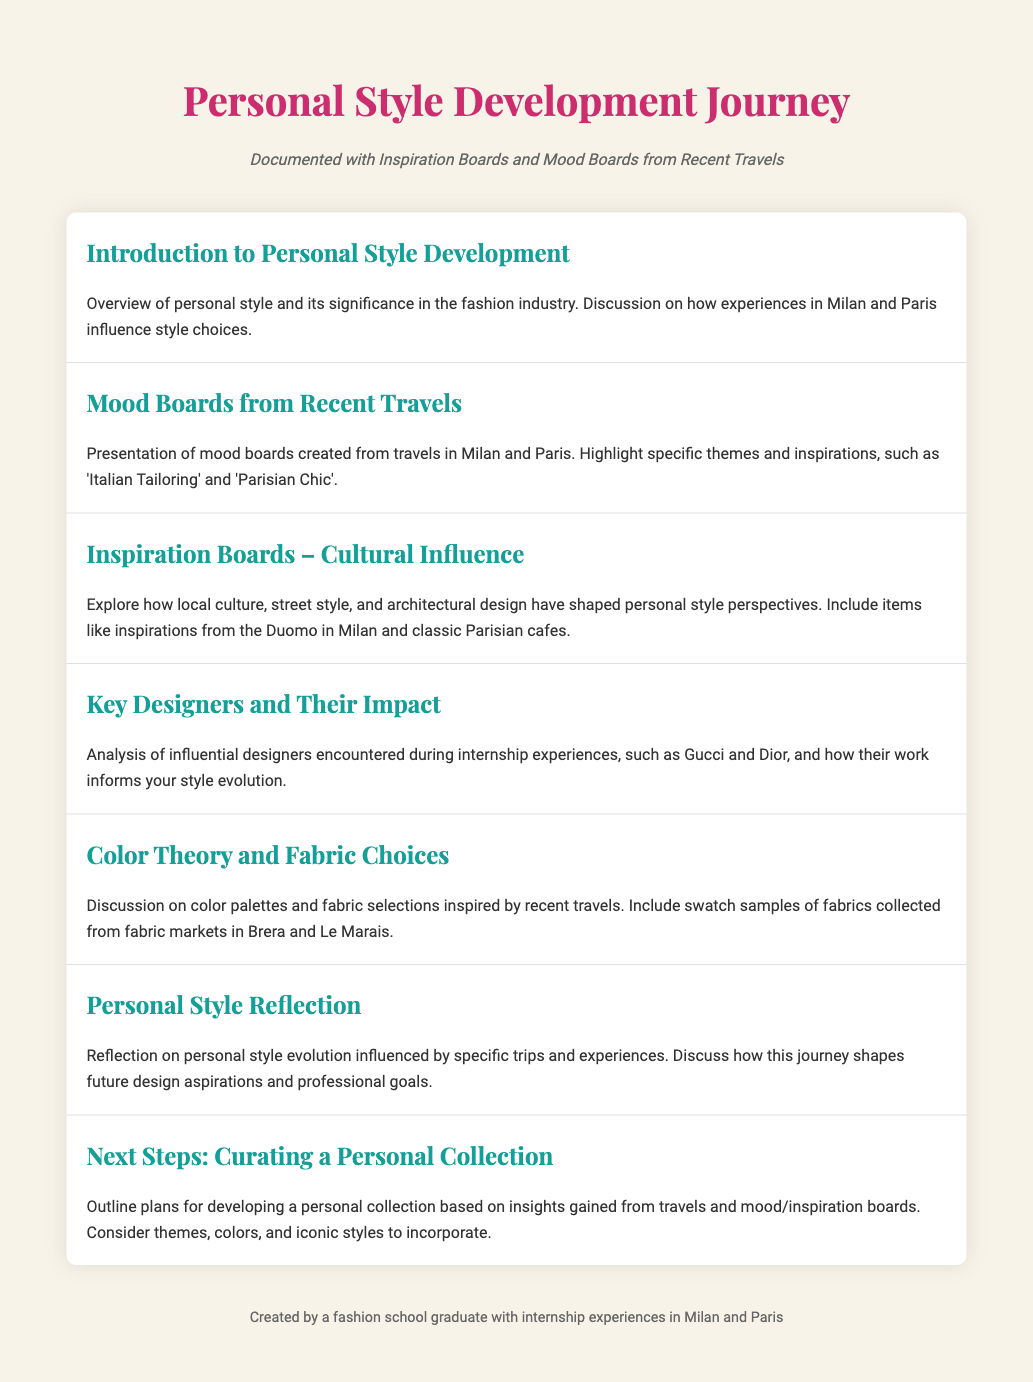What is the title of the document? The title is specified in the header section of the document.
Answer: Personal Style Development Journey What city is mentioned in relation to color palettes and fabric selections? The document discusses fabric selections specifically from a notable area.
Answer: Brera How many agenda items are there in total? The total number of agenda items is countable within the document.
Answer: 7 Which influential designer is mentioned first? The document lists designers encountered during internships, with a specific one highlighted first.
Answer: Gucci What theme is highlighted in the mood boards from travels? The document specifies themes related to the mood boards created during travels.
Answer: Italian Tailoring What does the final agenda item focus on? The last agenda item outlines plans for future actions to be taken based on the document's insights.
Answer: Curating a Personal Collection Which cultural influence is explored in the inspiration boards? The document mentions specific cultural aspects that shape style perspectives.
Answer: Local culture 